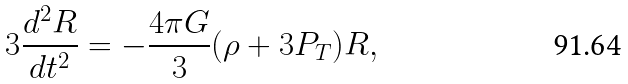Convert formula to latex. <formula><loc_0><loc_0><loc_500><loc_500>3 \frac { d ^ { 2 } R } { d t ^ { 2 } } = - { \frac { 4 \pi G } 3 } ( \rho + 3 P _ { T } ) R ,</formula> 